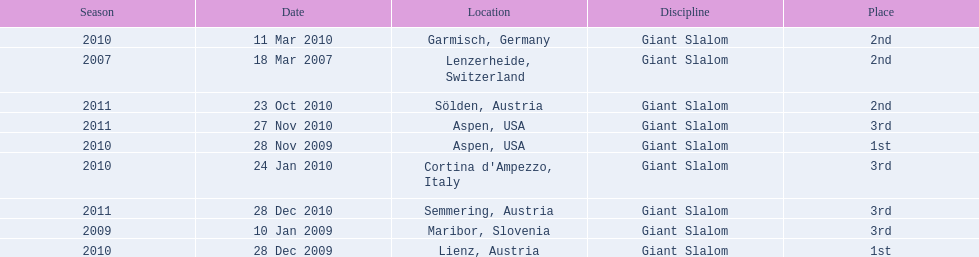The final race finishing place was not 1st but what other place? 3rd. 